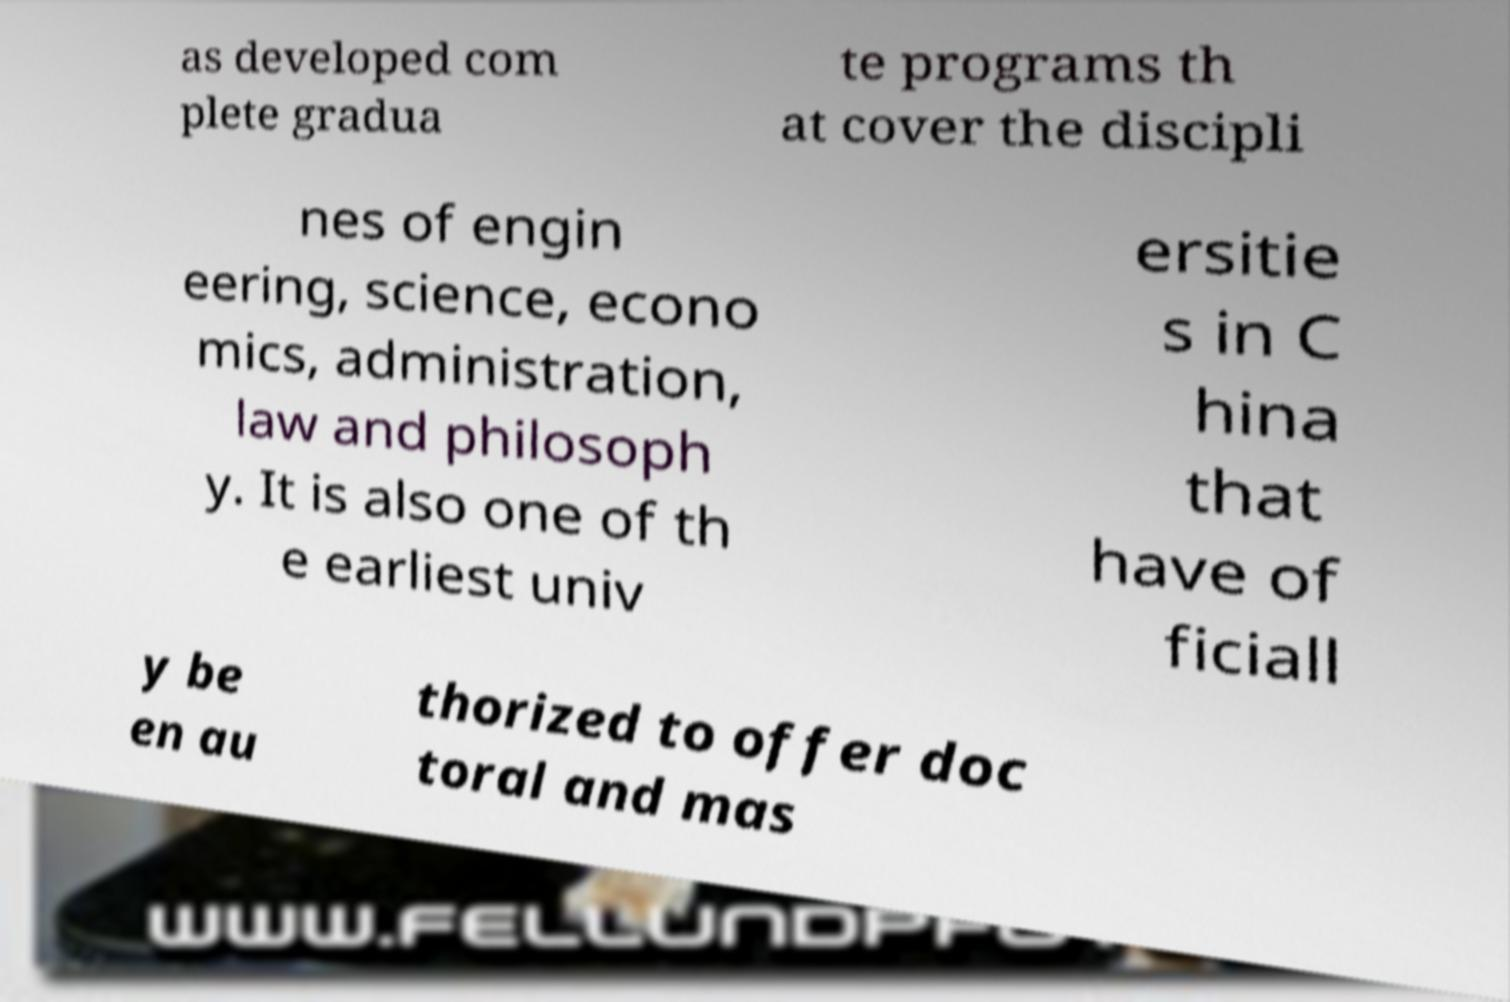What messages or text are displayed in this image? I need them in a readable, typed format. as developed com plete gradua te programs th at cover the discipli nes of engin eering, science, econo mics, administration, law and philosoph y. It is also one of th e earliest univ ersitie s in C hina that have of ficiall y be en au thorized to offer doc toral and mas 